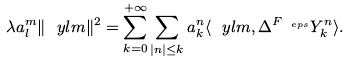<formula> <loc_0><loc_0><loc_500><loc_500>\lambda a _ { l } ^ { m } \| \ y l m \| ^ { 2 } = \sum _ { k = 0 } ^ { + \infty } \sum _ { | n | \leq k } a _ { k } ^ { n } \langle \ y l m , \Delta ^ { F _ { \ e p s } } Y _ { k } ^ { n } \rangle .</formula> 